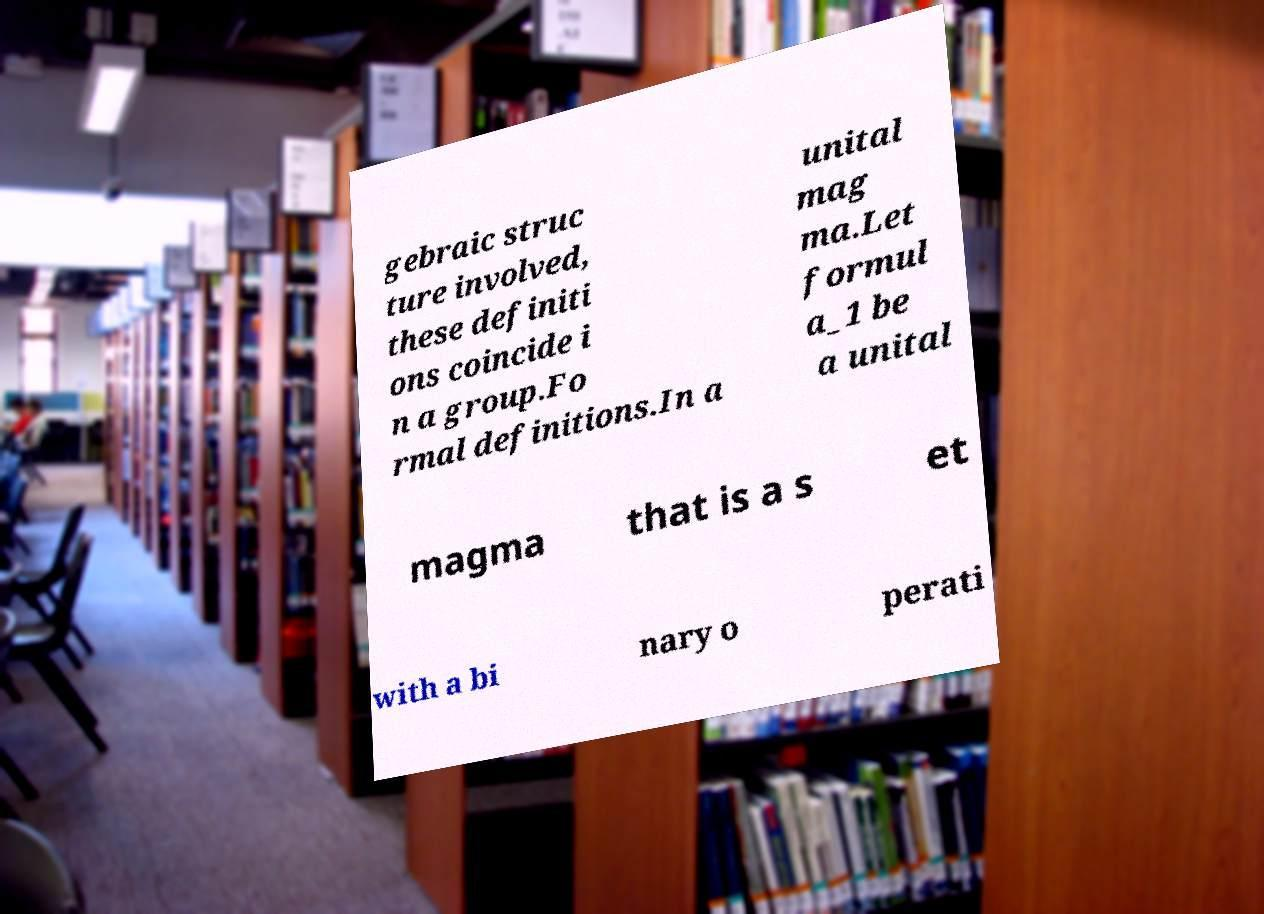Please read and relay the text visible in this image. What does it say? gebraic struc ture involved, these definiti ons coincide i n a group.Fo rmal definitions.In a unital mag ma.Let formul a_1 be a unital magma that is a s et with a bi nary o perati 